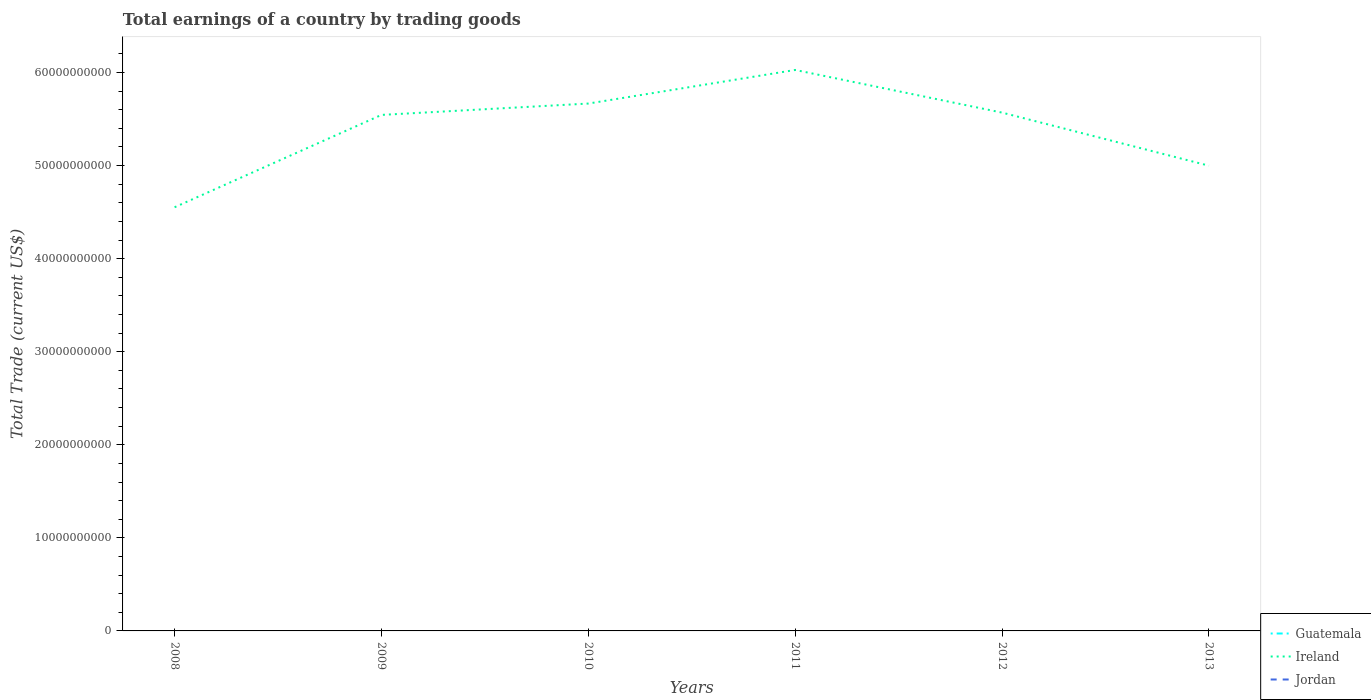How many different coloured lines are there?
Provide a short and direct response. 1. Does the line corresponding to Jordan intersect with the line corresponding to Guatemala?
Provide a succinct answer. No. Across all years, what is the maximum total earnings in Jordan?
Make the answer very short. 0. What is the total total earnings in Ireland in the graph?
Make the answer very short. -1.11e+1. What is the difference between the highest and the second highest total earnings in Ireland?
Keep it short and to the point. 1.48e+1. Is the total earnings in Ireland strictly greater than the total earnings in Guatemala over the years?
Your response must be concise. No. How many years are there in the graph?
Offer a very short reply. 6. Are the values on the major ticks of Y-axis written in scientific E-notation?
Keep it short and to the point. No. Does the graph contain any zero values?
Ensure brevity in your answer.  Yes. Does the graph contain grids?
Keep it short and to the point. No. Where does the legend appear in the graph?
Your answer should be very brief. Bottom right. How many legend labels are there?
Your answer should be very brief. 3. How are the legend labels stacked?
Provide a succinct answer. Vertical. What is the title of the graph?
Ensure brevity in your answer.  Total earnings of a country by trading goods. Does "Other small states" appear as one of the legend labels in the graph?
Keep it short and to the point. No. What is the label or title of the Y-axis?
Offer a very short reply. Total Trade (current US$). What is the Total Trade (current US$) of Ireland in 2008?
Your answer should be very brief. 4.55e+1. What is the Total Trade (current US$) in Guatemala in 2009?
Provide a short and direct response. 0. What is the Total Trade (current US$) of Ireland in 2009?
Ensure brevity in your answer.  5.54e+1. What is the Total Trade (current US$) of Jordan in 2009?
Ensure brevity in your answer.  0. What is the Total Trade (current US$) in Guatemala in 2010?
Provide a succinct answer. 0. What is the Total Trade (current US$) of Ireland in 2010?
Your answer should be very brief. 5.67e+1. What is the Total Trade (current US$) in Jordan in 2010?
Keep it short and to the point. 0. What is the Total Trade (current US$) in Guatemala in 2011?
Your answer should be compact. 0. What is the Total Trade (current US$) in Ireland in 2011?
Provide a succinct answer. 6.03e+1. What is the Total Trade (current US$) in Ireland in 2012?
Offer a terse response. 5.57e+1. What is the Total Trade (current US$) of Ireland in 2013?
Your response must be concise. 5.00e+1. Across all years, what is the maximum Total Trade (current US$) of Ireland?
Your response must be concise. 6.03e+1. Across all years, what is the minimum Total Trade (current US$) of Ireland?
Make the answer very short. 4.55e+1. What is the total Total Trade (current US$) in Ireland in the graph?
Offer a terse response. 3.24e+11. What is the total Total Trade (current US$) of Jordan in the graph?
Offer a terse response. 0. What is the difference between the Total Trade (current US$) of Ireland in 2008 and that in 2009?
Keep it short and to the point. -9.92e+09. What is the difference between the Total Trade (current US$) in Ireland in 2008 and that in 2010?
Provide a short and direct response. -1.11e+1. What is the difference between the Total Trade (current US$) of Ireland in 2008 and that in 2011?
Provide a succinct answer. -1.48e+1. What is the difference between the Total Trade (current US$) in Ireland in 2008 and that in 2012?
Offer a very short reply. -1.02e+1. What is the difference between the Total Trade (current US$) in Ireland in 2008 and that in 2013?
Ensure brevity in your answer.  -4.47e+09. What is the difference between the Total Trade (current US$) in Ireland in 2009 and that in 2010?
Keep it short and to the point. -1.22e+09. What is the difference between the Total Trade (current US$) in Ireland in 2009 and that in 2011?
Offer a terse response. -4.83e+09. What is the difference between the Total Trade (current US$) in Ireland in 2009 and that in 2012?
Your answer should be compact. -2.46e+08. What is the difference between the Total Trade (current US$) of Ireland in 2009 and that in 2013?
Your answer should be compact. 5.46e+09. What is the difference between the Total Trade (current US$) in Ireland in 2010 and that in 2011?
Ensure brevity in your answer.  -3.61e+09. What is the difference between the Total Trade (current US$) in Ireland in 2010 and that in 2012?
Ensure brevity in your answer.  9.75e+08. What is the difference between the Total Trade (current US$) of Ireland in 2010 and that in 2013?
Your response must be concise. 6.68e+09. What is the difference between the Total Trade (current US$) in Ireland in 2011 and that in 2012?
Give a very brief answer. 4.58e+09. What is the difference between the Total Trade (current US$) in Ireland in 2011 and that in 2013?
Provide a succinct answer. 1.03e+1. What is the difference between the Total Trade (current US$) of Ireland in 2012 and that in 2013?
Your answer should be very brief. 5.70e+09. What is the average Total Trade (current US$) of Ireland per year?
Your answer should be compact. 5.39e+1. What is the ratio of the Total Trade (current US$) of Ireland in 2008 to that in 2009?
Give a very brief answer. 0.82. What is the ratio of the Total Trade (current US$) in Ireland in 2008 to that in 2010?
Provide a short and direct response. 0.8. What is the ratio of the Total Trade (current US$) in Ireland in 2008 to that in 2011?
Offer a terse response. 0.76. What is the ratio of the Total Trade (current US$) of Ireland in 2008 to that in 2012?
Your answer should be very brief. 0.82. What is the ratio of the Total Trade (current US$) in Ireland in 2008 to that in 2013?
Provide a succinct answer. 0.91. What is the ratio of the Total Trade (current US$) in Ireland in 2009 to that in 2010?
Your answer should be compact. 0.98. What is the ratio of the Total Trade (current US$) of Ireland in 2009 to that in 2011?
Provide a short and direct response. 0.92. What is the ratio of the Total Trade (current US$) in Ireland in 2009 to that in 2013?
Offer a terse response. 1.11. What is the ratio of the Total Trade (current US$) of Ireland in 2010 to that in 2011?
Your response must be concise. 0.94. What is the ratio of the Total Trade (current US$) of Ireland in 2010 to that in 2012?
Keep it short and to the point. 1.02. What is the ratio of the Total Trade (current US$) in Ireland in 2010 to that in 2013?
Make the answer very short. 1.13. What is the ratio of the Total Trade (current US$) in Ireland in 2011 to that in 2012?
Make the answer very short. 1.08. What is the ratio of the Total Trade (current US$) in Ireland in 2011 to that in 2013?
Provide a succinct answer. 1.21. What is the ratio of the Total Trade (current US$) of Ireland in 2012 to that in 2013?
Offer a terse response. 1.11. What is the difference between the highest and the second highest Total Trade (current US$) of Ireland?
Offer a terse response. 3.61e+09. What is the difference between the highest and the lowest Total Trade (current US$) of Ireland?
Offer a terse response. 1.48e+1. 